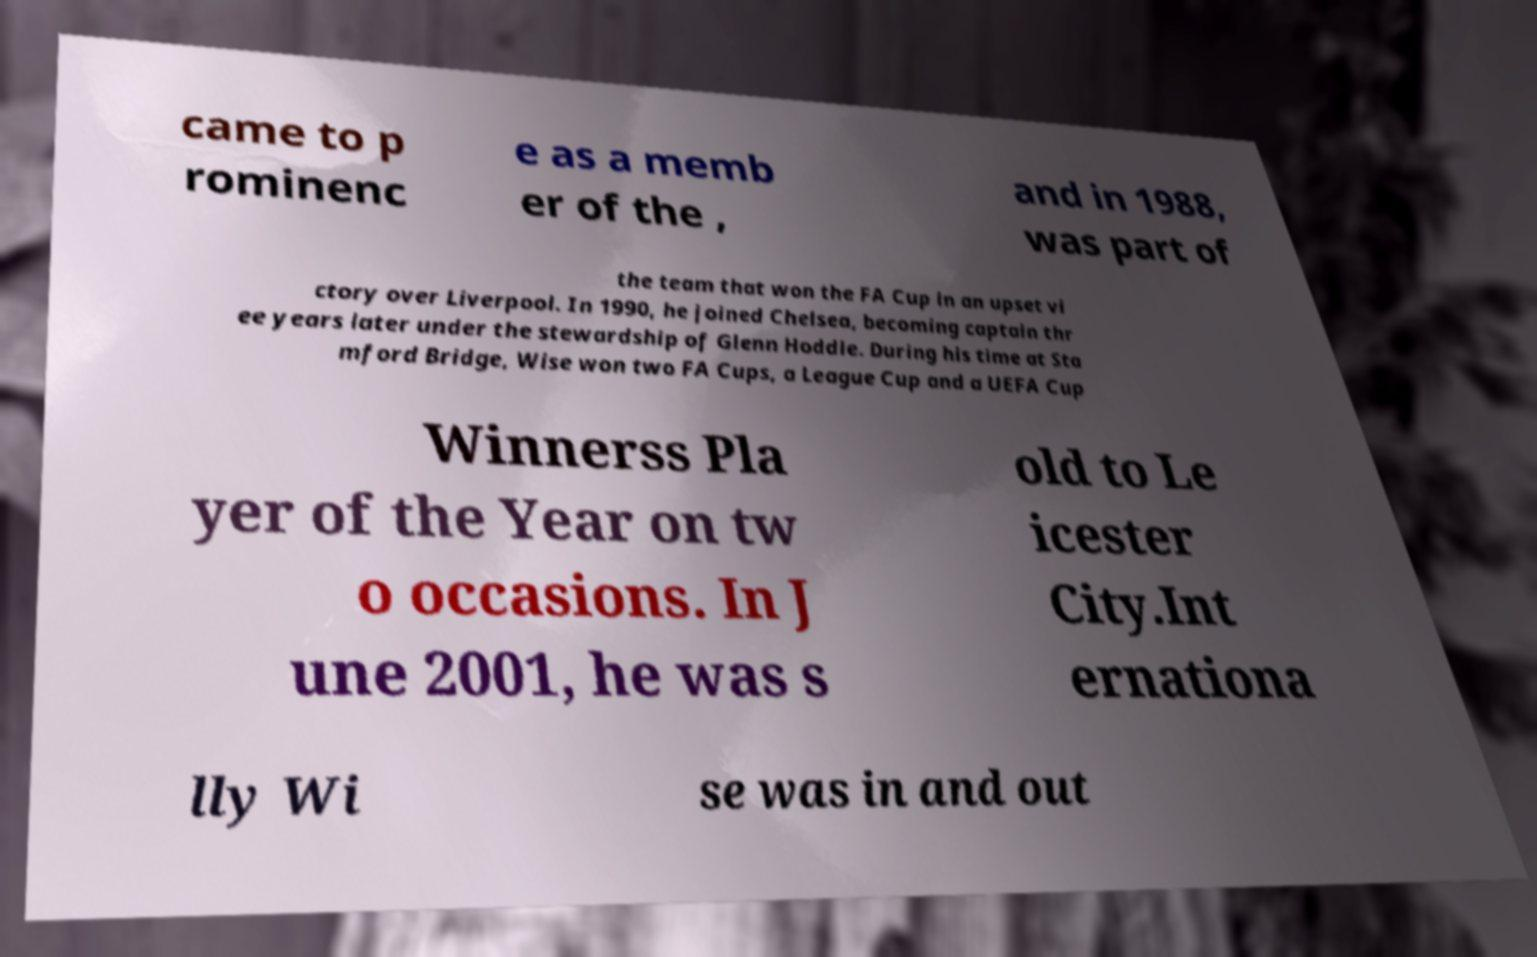Please read and relay the text visible in this image. What does it say? came to p rominenc e as a memb er of the , and in 1988, was part of the team that won the FA Cup in an upset vi ctory over Liverpool. In 1990, he joined Chelsea, becoming captain thr ee years later under the stewardship of Glenn Hoddle. During his time at Sta mford Bridge, Wise won two FA Cups, a League Cup and a UEFA Cup Winnerss Pla yer of the Year on tw o occasions. In J une 2001, he was s old to Le icester City.Int ernationa lly Wi se was in and out 